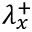Convert formula to latex. <formula><loc_0><loc_0><loc_500><loc_500>\lambda _ { x } ^ { + }</formula> 